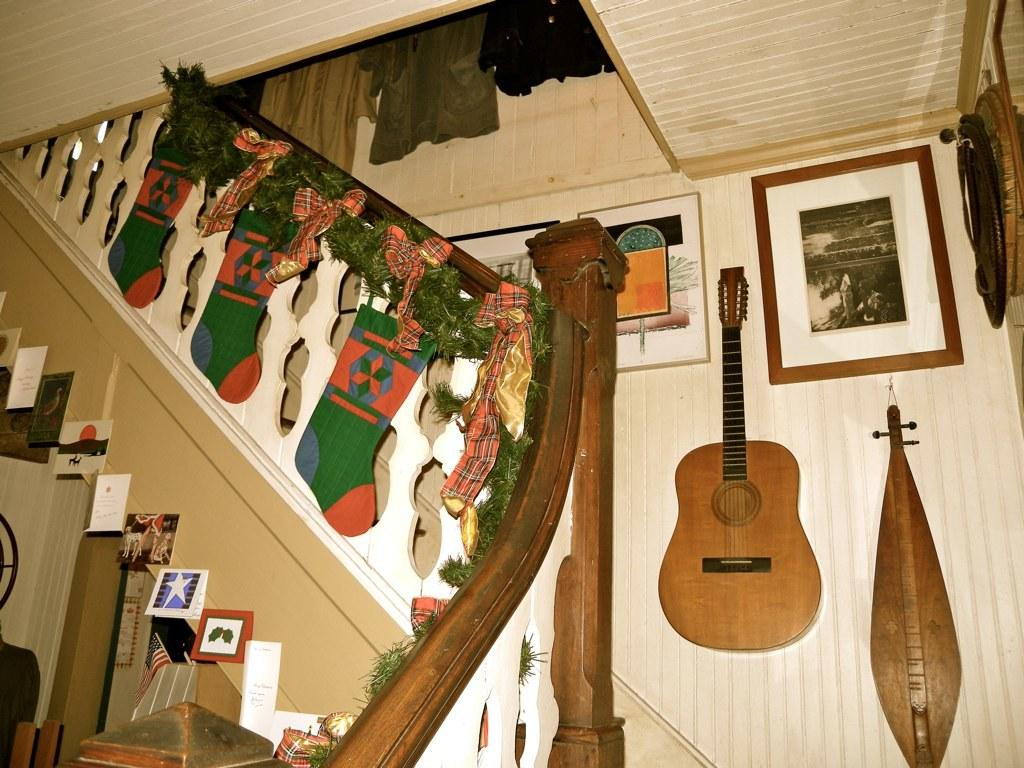What musical instrument is present in the image? There is a guitar in the image. What can be seen on the wall in the image? There are photo frames on the wall. Where are the socks located in the image? The socks are hanging on the stairs. What type of governor is mentioned in the image? There is no mention of a governor in the image. Can you see any harbors or boats in the image? There are no harbors or boats present in the image. 